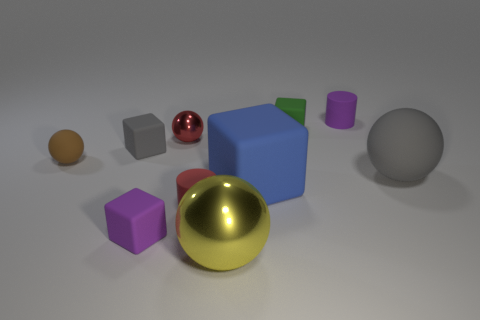Subtract all cylinders. How many objects are left? 8 Add 7 large brown rubber spheres. How many large brown rubber spheres exist? 7 Subtract 0 blue cylinders. How many objects are left? 10 Subtract all small rubber spheres. Subtract all tiny green blocks. How many objects are left? 8 Add 8 tiny green matte blocks. How many tiny green matte blocks are left? 9 